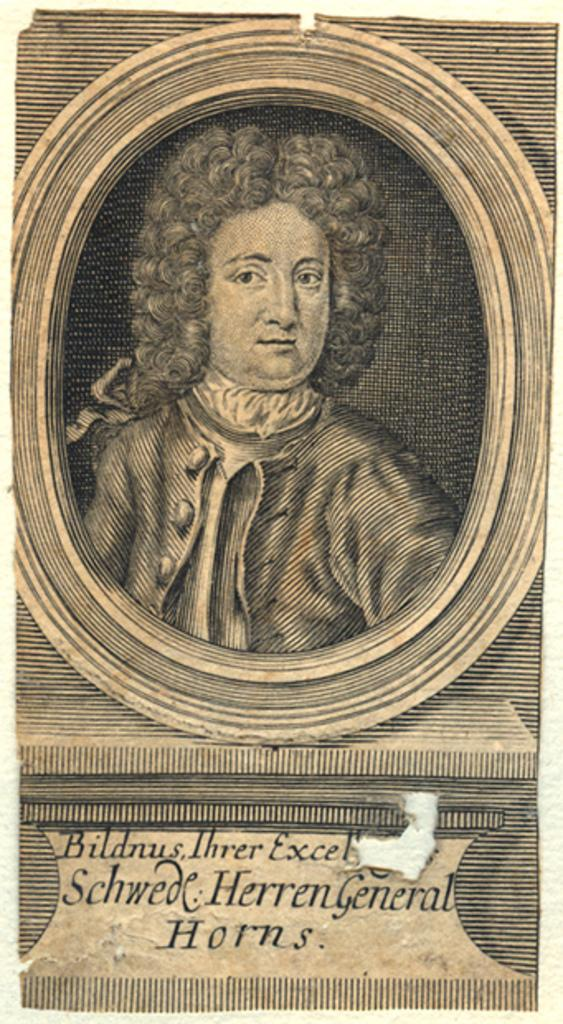<image>
Offer a succinct explanation of the picture presented. The portrait of a 1700s style gentleman has a caption reading Schwede Herren General Horns. 